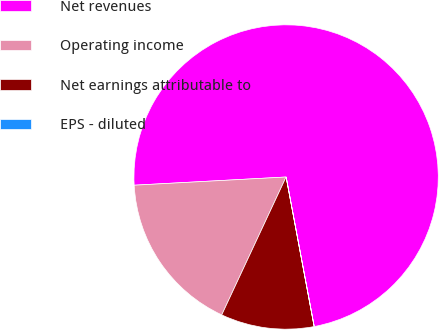<chart> <loc_0><loc_0><loc_500><loc_500><pie_chart><fcel>Net revenues<fcel>Operating income<fcel>Net earnings attributable to<fcel>EPS - diluted<nl><fcel>72.9%<fcel>17.19%<fcel>9.9%<fcel>0.01%<nl></chart> 